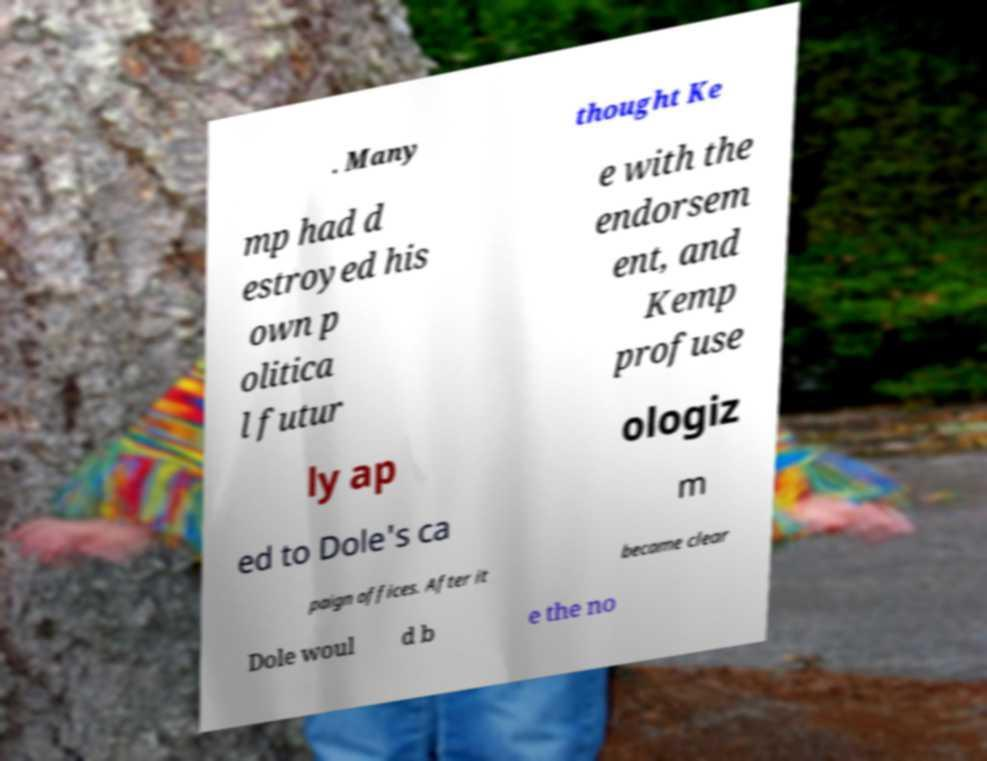Please identify and transcribe the text found in this image. . Many thought Ke mp had d estroyed his own p olitica l futur e with the endorsem ent, and Kemp profuse ly ap ologiz ed to Dole's ca m paign offices. After it became clear Dole woul d b e the no 